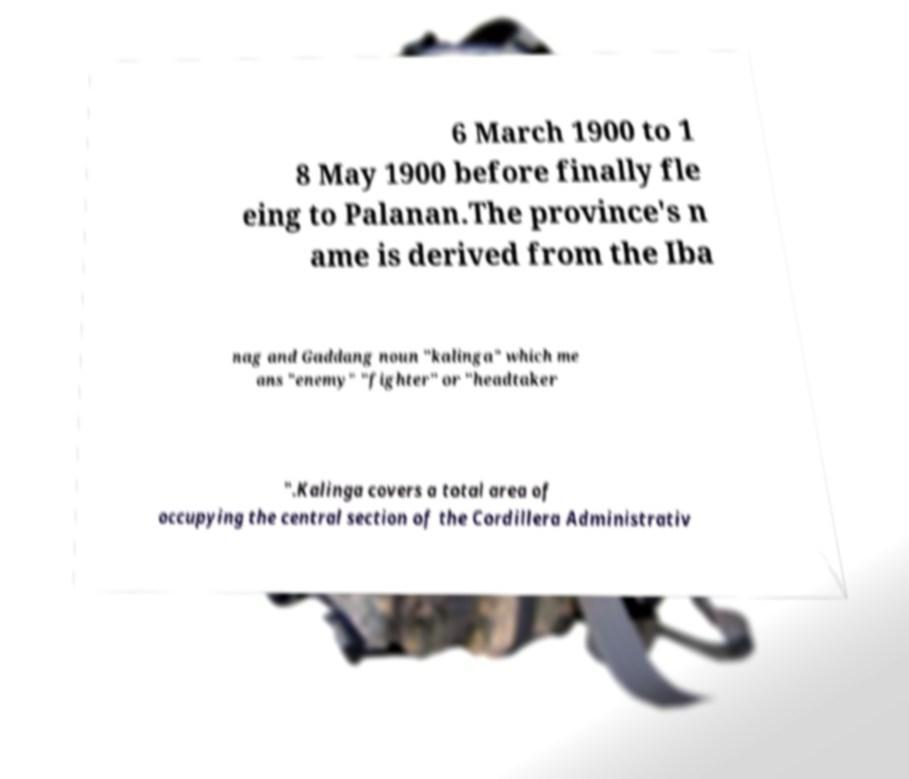For documentation purposes, I need the text within this image transcribed. Could you provide that? 6 March 1900 to 1 8 May 1900 before finally fle eing to Palanan.The province's n ame is derived from the Iba nag and Gaddang noun "kalinga" which me ans "enemy" "fighter" or "headtaker ".Kalinga covers a total area of occupying the central section of the Cordillera Administrativ 